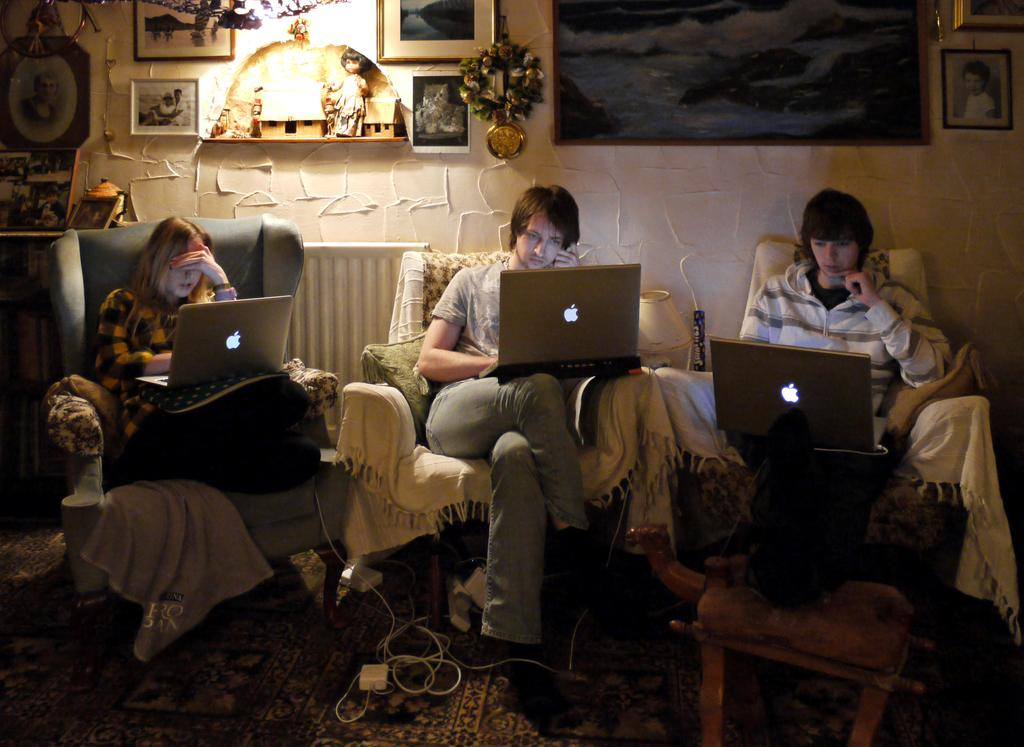What are the people in the image doing? The people in the image are sitting on couches. What objects are the people holding? The people are holding laptops. What type of floor covering is present in the image? There is a carpet on the floor in the image. What additional decorative elements can be seen in the image? Decorations are present in the image. What might be used for connecting electronic devices in the image? Cables are visible in the image. What is attached to the wall in the image? Wall hangings are attached to the wall in the image. What type of sheet is covering the drum in the image? There is no drum or sheet present in the image. 